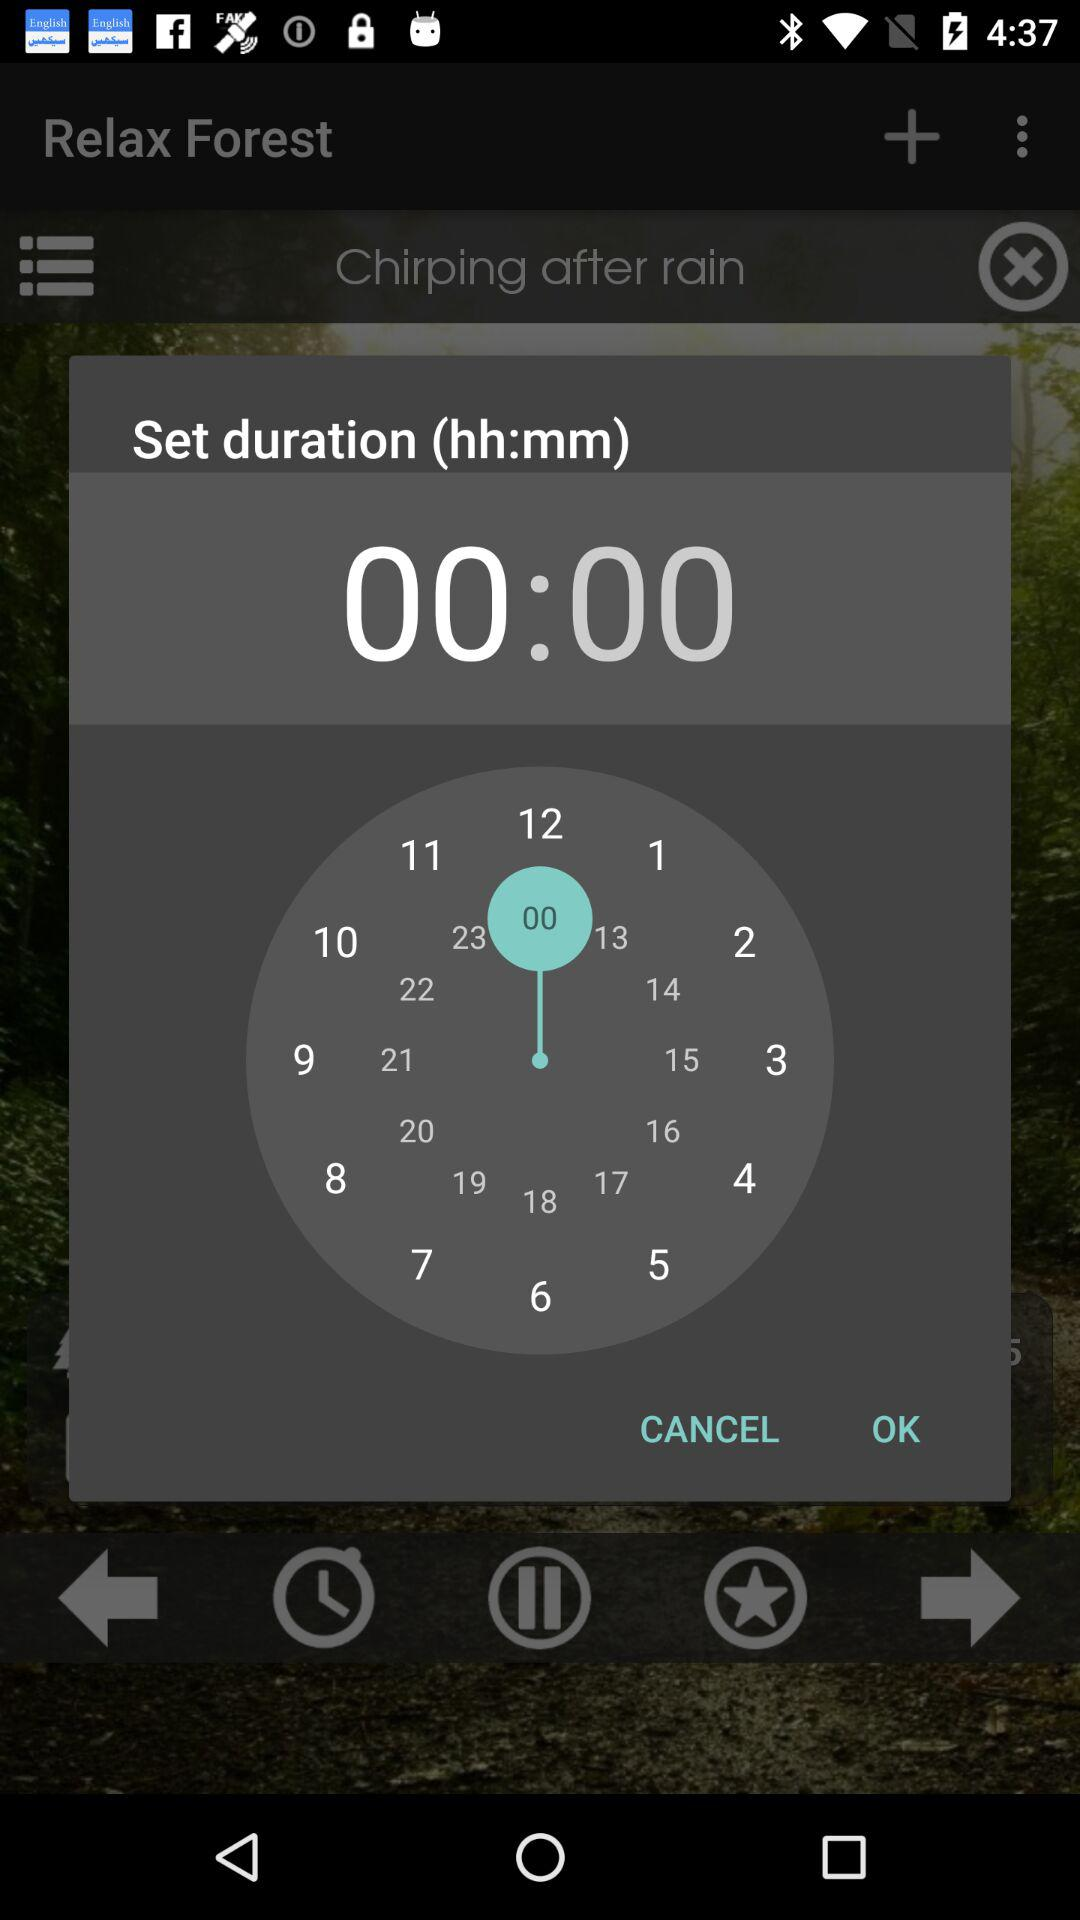How many numbers are in the countdown clock?
Answer the question using a single word or phrase. 12 